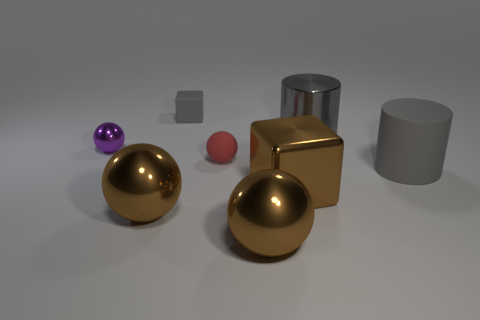Subtract 1 balls. How many balls are left? 3 Add 1 gray things. How many objects exist? 9 Subtract all cylinders. How many objects are left? 6 Subtract 0 green cubes. How many objects are left? 8 Subtract all large brown metal spheres. Subtract all tiny metal objects. How many objects are left? 5 Add 2 gray shiny cylinders. How many gray shiny cylinders are left? 3 Add 2 large gray rubber things. How many large gray rubber things exist? 3 